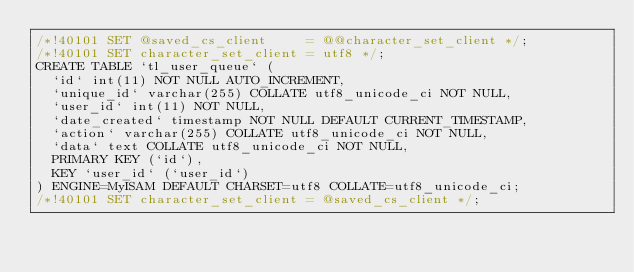Convert code to text. <code><loc_0><loc_0><loc_500><loc_500><_SQL_>/*!40101 SET @saved_cs_client     = @@character_set_client */;
/*!40101 SET character_set_client = utf8 */;
CREATE TABLE `tl_user_queue` (
  `id` int(11) NOT NULL AUTO_INCREMENT,
  `unique_id` varchar(255) COLLATE utf8_unicode_ci NOT NULL,
  `user_id` int(11) NOT NULL,
  `date_created` timestamp NOT NULL DEFAULT CURRENT_TIMESTAMP,
  `action` varchar(255) COLLATE utf8_unicode_ci NOT NULL,
  `data` text COLLATE utf8_unicode_ci NOT NULL,
  PRIMARY KEY (`id`),
  KEY `user_id` (`user_id`)
) ENGINE=MyISAM DEFAULT CHARSET=utf8 COLLATE=utf8_unicode_ci;
/*!40101 SET character_set_client = @saved_cs_client */;
</code> 